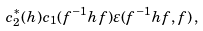<formula> <loc_0><loc_0><loc_500><loc_500>c _ { 2 } ^ { * } ( h ) c _ { 1 } ( f ^ { - 1 } h f ) \varepsilon ( f ^ { - 1 } h f , f ) \, ,</formula> 